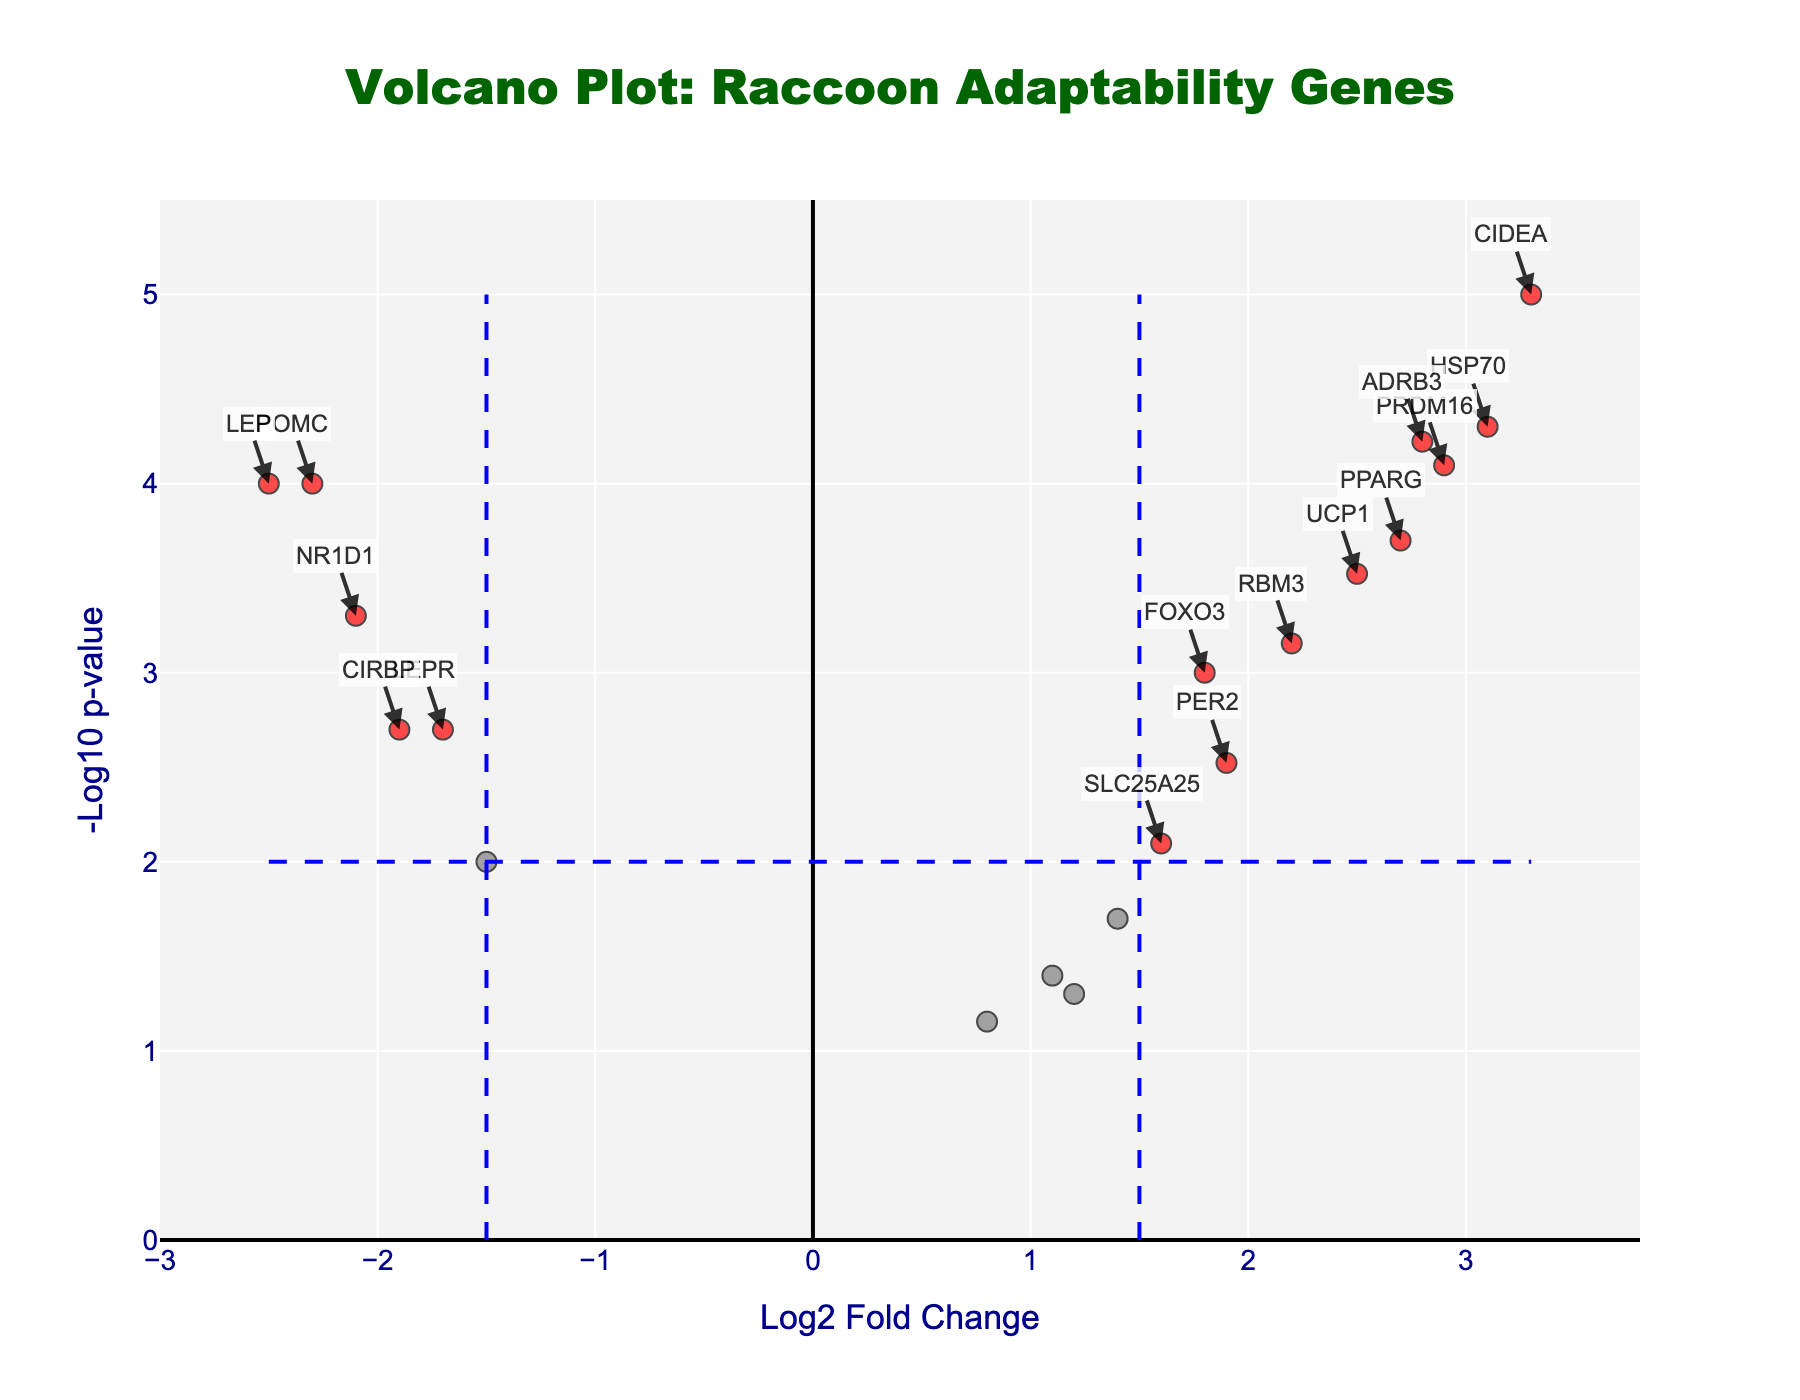what is the y-axis title in the figure? The y-axis title is a label that appears along the vertical axis, which describes what this axis represents in the plot. In this case, it represents the transformed p-values on a logarithmic scale.
Answer: -Log10 p-value What color are the most significant genes highlighted in? The genes that are considered most significant, based on the thresholds, are visually highlighted with a specific color to emphasize them. In this figure, these genes are highlighted in red.
Answer: Red How many genes meet both the fold change and p-value thresholds? To find the number of genes meeting the thresholds, look for data points that are both outside the log2 fold change of ±1.5 and below the p-value of 0.01. These data points are highlighted in red. Counting them gives the result.
Answer: 11 Which gene has the highest log2 fold change value among the significant genes? Among the significant genes, the one with the highest log2 fold change value will be the one furthest to the right on the x-axis. By examining the figure, this gene can be identified.
Answer: CIDEA What is the approximate -Log10 p-value threshold line level? The threshold line for -Log10 p-value is drawn to visually represent the significant p-value cutoff, typically marking significant limits. To determine this level, identify the horizontal dashed line’s position.
Answer: 2 Which genes are downregulated and significant based on the plot? Downregulated genes have negative log2 fold change values. By examining those that meet the log2 fold change and p-value thresholds (highlighted in red and located on the left), the specific genes can be identified.
Answer: POMC, CRY1, NR1D1, LEP What range is covered by the x-axis in the plot? The x-axis represents the log2 fold change and its range extends from the smallest to the largest value, including a slight buffer around these values. By looking at the x-axis limits, this range can be determined.
Answer: Approximately -3.0 to 3.8 How does the significance of HSP70 compare to LEP in terms of p-value? To compare the significance, look at the -Log10 p-value for both HSP70 and LEP and determine which one is higher. A higher -Log10 p-value indicates a lower p-value and thus higher significance.
Answer: HSP70 is more significant than LEP 